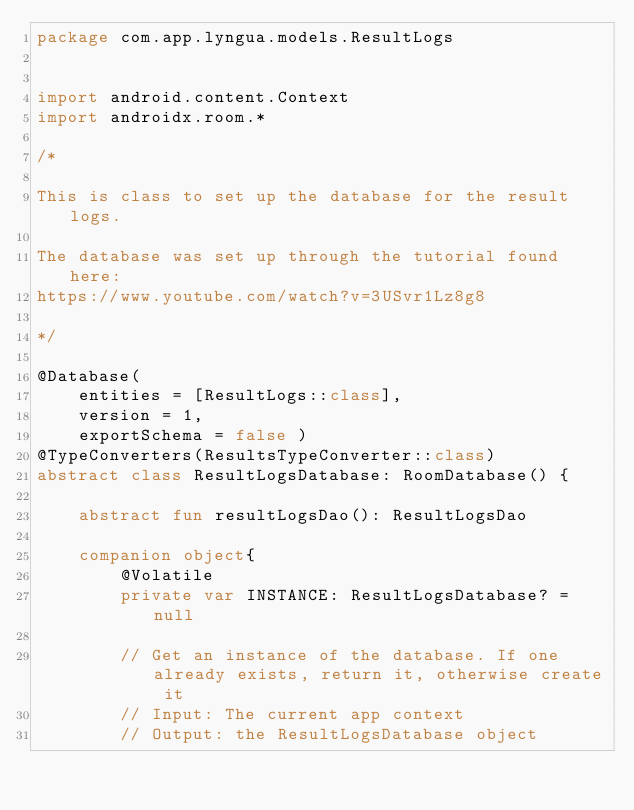Convert code to text. <code><loc_0><loc_0><loc_500><loc_500><_Kotlin_>package com.app.lyngua.models.ResultLogs


import android.content.Context
import androidx.room.*

/*

This is class to set up the database for the result logs.

The database was set up through the tutorial found here:
https://www.youtube.com/watch?v=3USvr1Lz8g8

*/

@Database(
    entities = [ResultLogs::class],
    version = 1,
    exportSchema = false )
@TypeConverters(ResultsTypeConverter::class)
abstract class ResultLogsDatabase: RoomDatabase() {

    abstract fun resultLogsDao(): ResultLogsDao

    companion object{
        @Volatile
        private var INSTANCE: ResultLogsDatabase? = null

        // Get an instance of the database. If one already exists, return it, otherwise create it
        // Input: The current app context
        // Output: the ResultLogsDatabase object</code> 